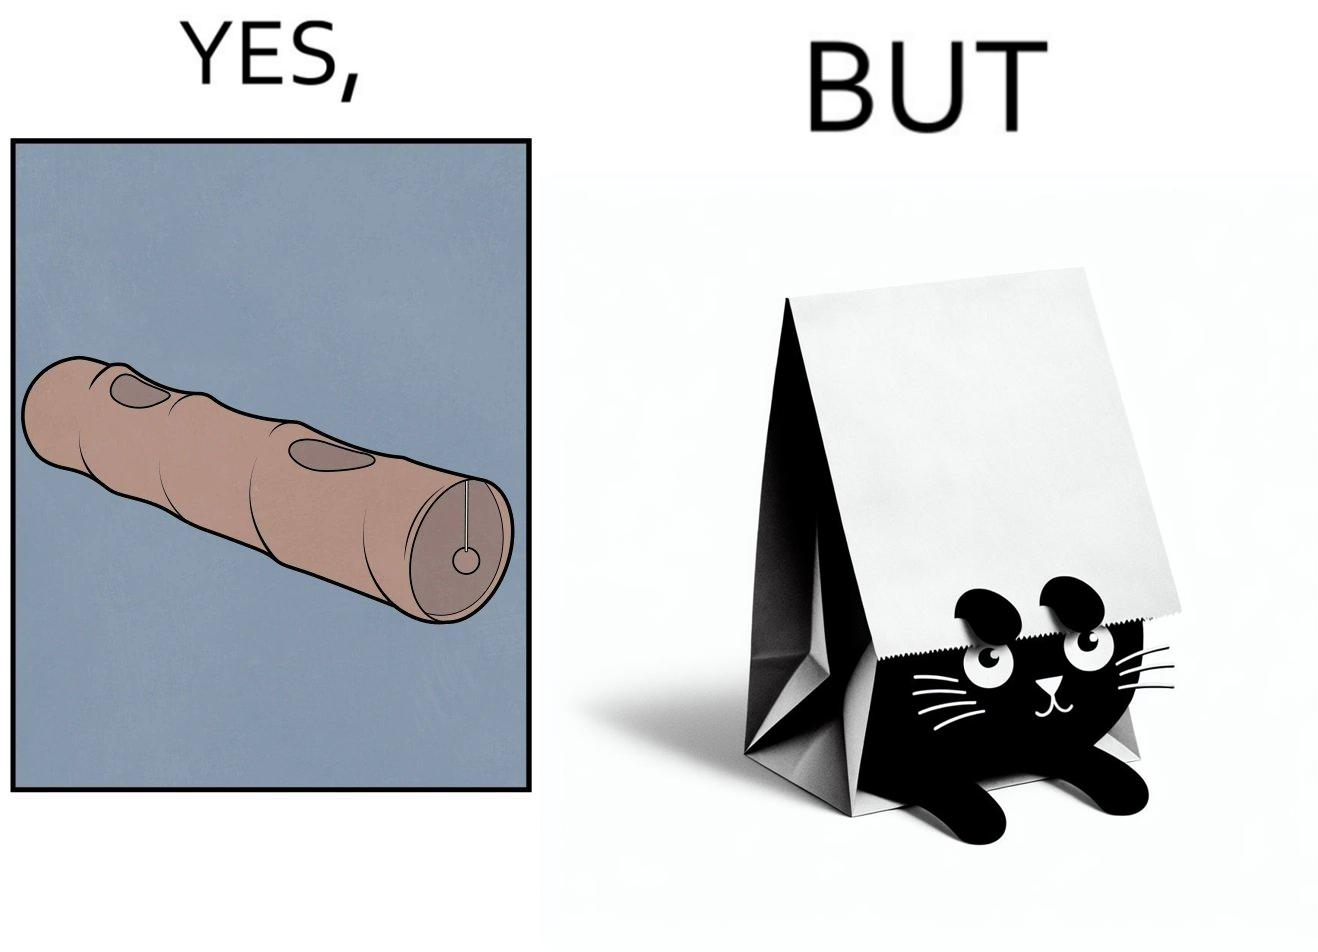What is shown in this image? The image is funny, because even when there is a dedicated thing for the animal to play with it still is hiding itself in the paper bag 